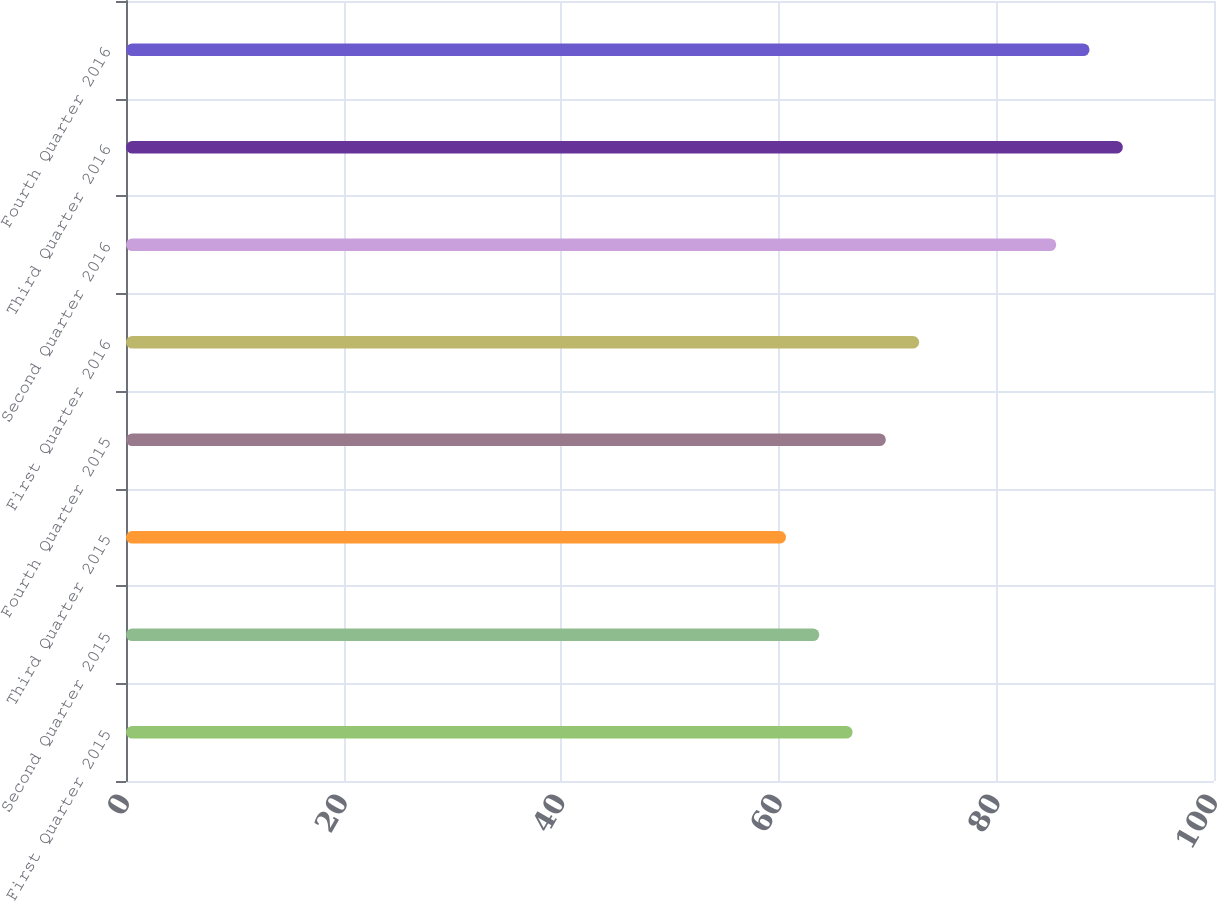Convert chart to OTSL. <chart><loc_0><loc_0><loc_500><loc_500><bar_chart><fcel>First Quarter 2015<fcel>Second Quarter 2015<fcel>Third Quarter 2015<fcel>Fourth Quarter 2015<fcel>First Quarter 2016<fcel>Second Quarter 2016<fcel>Third Quarter 2016<fcel>Fourth Quarter 2016<nl><fcel>66.78<fcel>63.72<fcel>60.66<fcel>69.84<fcel>72.9<fcel>85.5<fcel>91.62<fcel>88.56<nl></chart> 